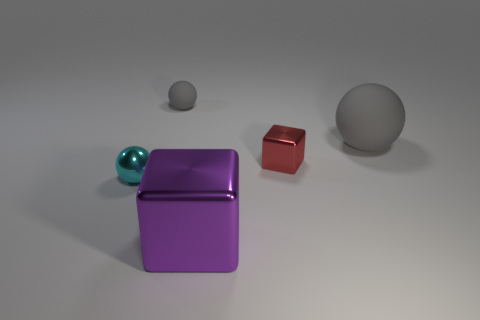Are there an equal number of small rubber things that are in front of the large gray sphere and small green rubber cubes?
Provide a succinct answer. Yes. What is the shape of the red metal thing?
Provide a succinct answer. Cube. Is there any other thing that is the same color as the tiny rubber thing?
Your answer should be compact. Yes. There is a cube that is behind the big metallic cube; does it have the same size as the metal block in front of the tiny red object?
Offer a very short reply. No. What is the shape of the large purple shiny thing to the right of the matte sphere that is on the left side of the large metal block?
Your answer should be compact. Cube. Does the purple metal block have the same size as the red block that is on the right side of the small cyan metal thing?
Your answer should be very brief. No. What size is the gray matte ball that is in front of the gray rubber sphere that is on the left side of the cube that is in front of the small red metallic object?
Offer a very short reply. Large. How many objects are either spheres behind the big matte ball or tiny purple metal balls?
Offer a terse response. 1. What number of matte balls are in front of the gray rubber object that is right of the big metal cube?
Offer a very short reply. 0. Are there more gray matte balls that are to the left of the cyan metallic sphere than large red cylinders?
Give a very brief answer. No. 